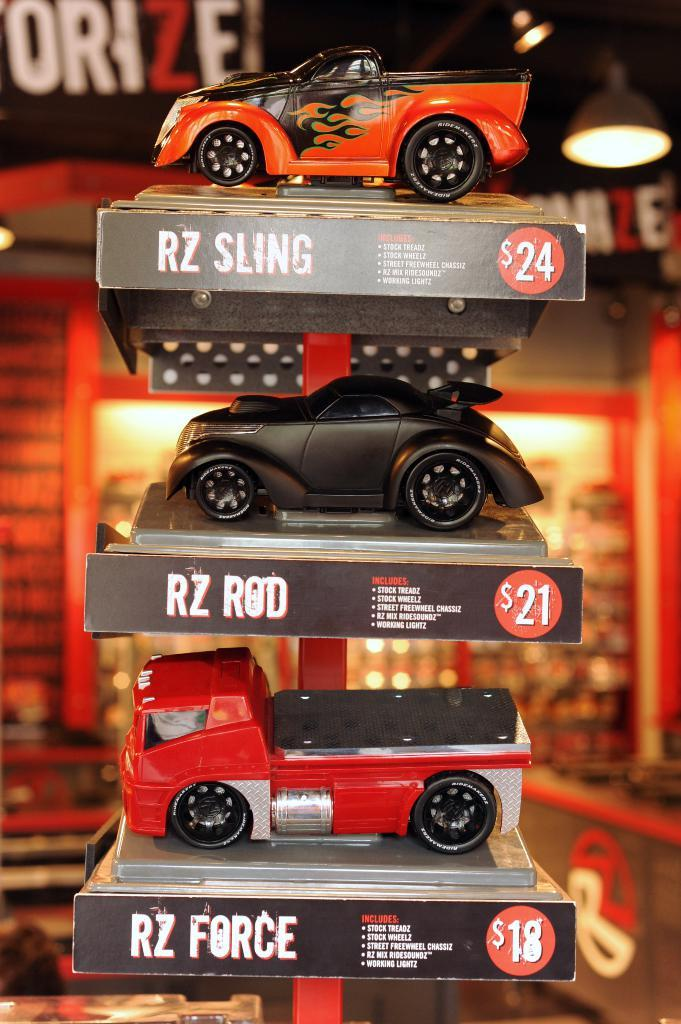What type of objects are on the shelves in the image? There are toy vehicles on the shelves in the image. What additional information is provided about the toy vehicles? There is some text associated with the toy vehicles. What can be seen at the top of the roof in the image? There are lights visible at the top of the roof in the image. What type of note is being passed between the toy vehicles in the image? There are no toy vehicles interacting with each other or passing notes in the image. 